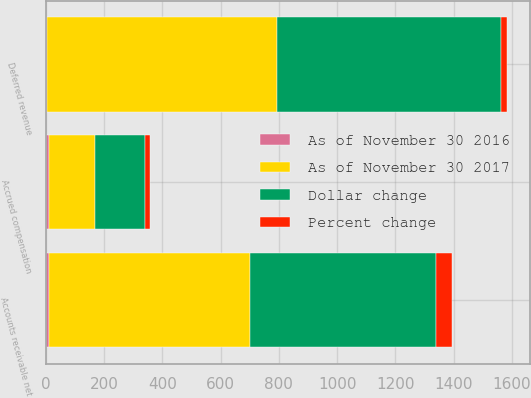Convert chart to OTSL. <chart><loc_0><loc_0><loc_500><loc_500><stacked_bar_chart><ecel><fcel>Accounts receivable net<fcel>Accrued compensation<fcel>Deferred revenue<nl><fcel>As of November 30 2017<fcel>693.5<fcel>157.4<fcel>790.8<nl><fcel>Dollar change<fcel>635.6<fcel>174<fcel>770.2<nl><fcel>Percent change<fcel>57.9<fcel>16.6<fcel>20.6<nl><fcel>As of November 30 2016<fcel>9<fcel>10<fcel>3<nl></chart> 